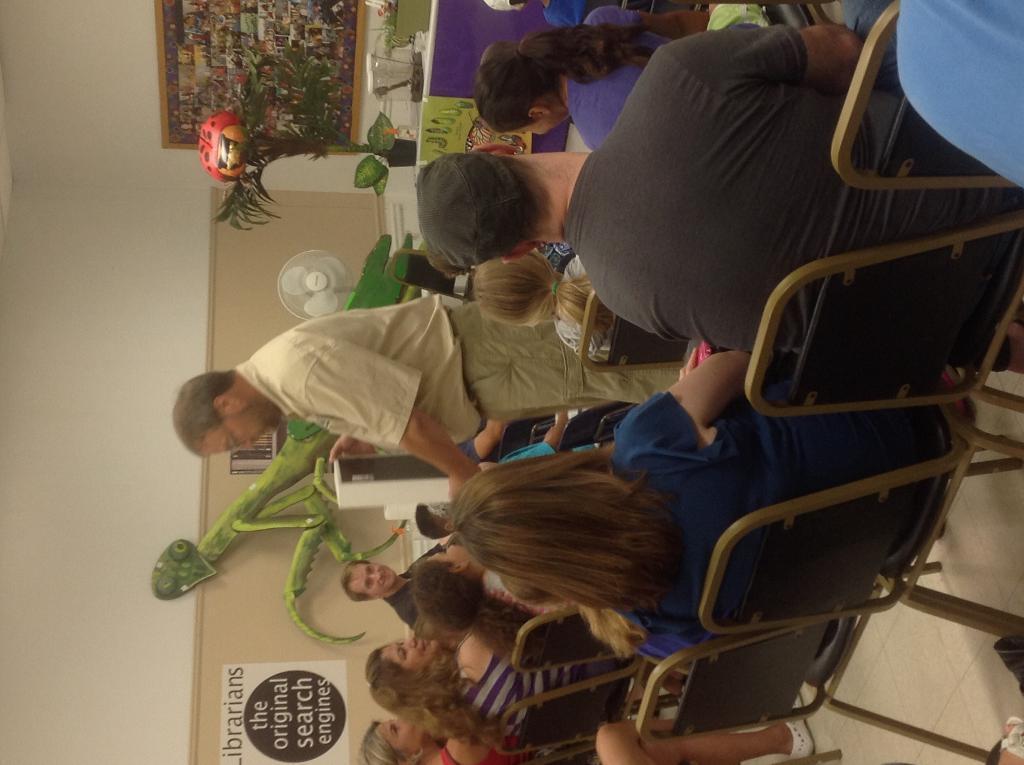Could you give a brief overview of what you see in this image? This image is in left direction. In the middle of the image there is a man standing. Around him few people are sitting on the chairs and looking at this man. In the background there is a table fan and few objects. At the top of the image there are few plants placed on a table and a frame is attached to the wall. On the left side, I can see the wall and there is a poster attached to it. 